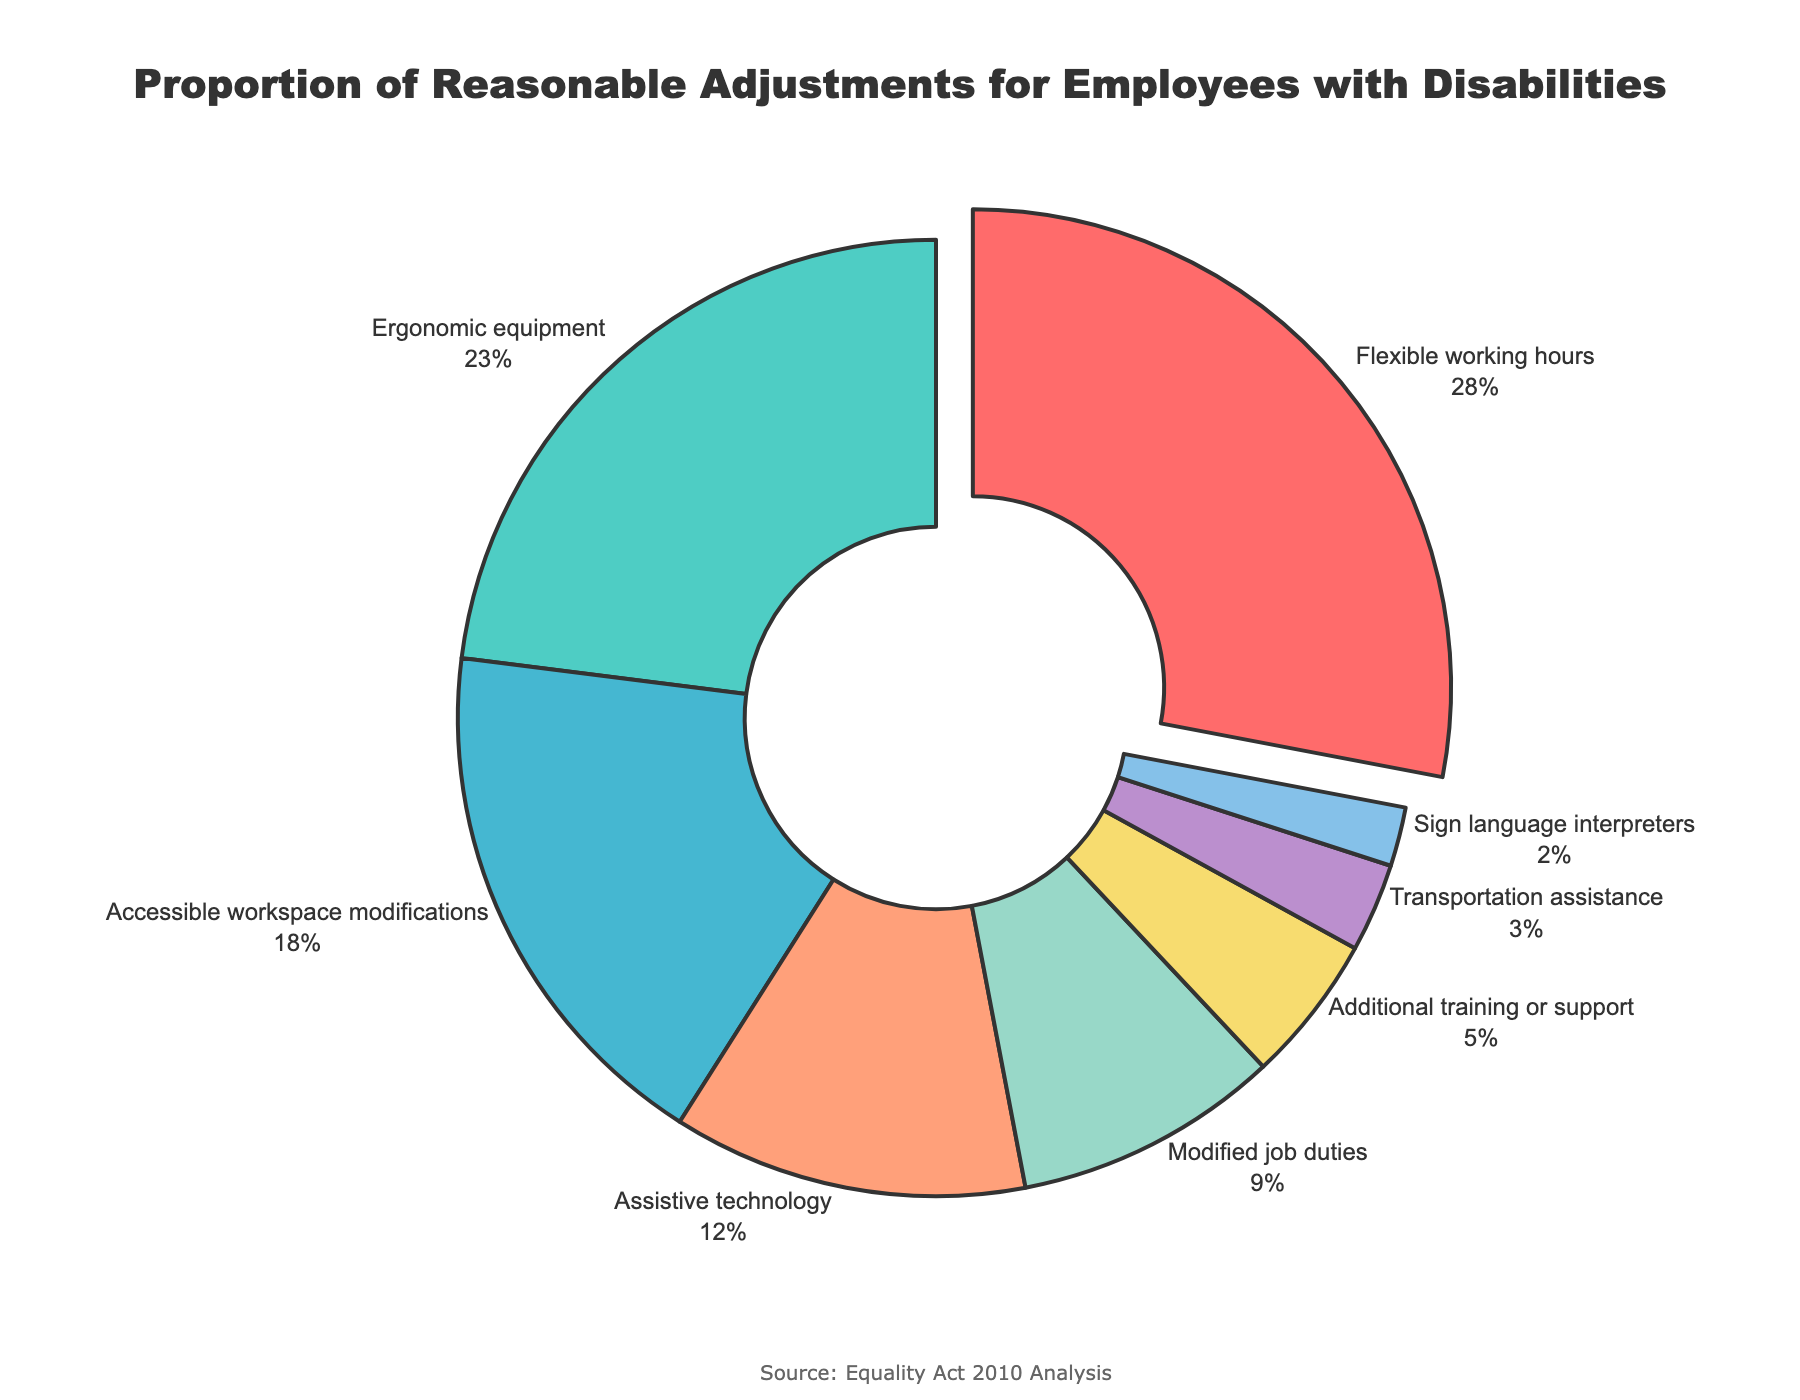What's the category with the highest proportion of reasonable adjustments? The category with the highest percentage in the pie chart is depicted with a slight pull-out effect, and labeled as "Flexible working hours" with 28%.
Answer: Flexible working hours What is the combined percentage of "Ergonomic equipment" and "Accessible workspace modifications"? The percentages for "Ergonomic equipment" and "Accessible workspace modifications" are 23% and 18% respectively. Adding these together, we get 23% + 18% = 41%.
Answer: 41% Which category has a lower proportion: "Modified job duties" or "Assistive technology"? By comparing the percentages in the pie chart, "Modified job duties" has a percentage of 9% and "Assistive technology" has 12%. Since 9% < 12%, "Modified job duties" has a lower proportion.
Answer: Modified job duties What's the difference in the proportion between the highest and the lowest categories? The highest proportion is for "Flexible working hours" at 28%. The lowest proportion is for "Sign language interpreters" at 2%. The difference is 28% - 2% = 26%.
Answer: 26% What is the total percentage of the three least common reasonable adjustments? The three least common categories are "Sign language interpreters" (2%), "Transportation assistance" (3%), and "Additional training or support" (5%). Adding these together, we get 2% + 3% + 5% = 10%.
Answer: 10% How much more common is "Ergonomic equipment" compared to "Modified job duties"? "Ergonomic equipment" is 23% and "Modified job duties" is 9%. To find how much more common it is: 23% - 9% = 14%.
Answer: 14% What's the total percentage for all the categories related to physical modifications? The categories related to physical modifications are "Ergonomic equipment" (23%), "Accessible workspace modifications" (18%), "Transportation assistance" (3%). Adding these together, we get 23% + 18% + 3% = 44%.
Answer: 44% What's the proportion of categories that each constitute less than 10%? The categories with less than 10% are "Modified job duties" (9%), "Additional training or support" (5%), "Transportation assistance" (3%), and "Sign language interpreters" (2%). These total to 9% + 5% + 3% + 2% = 19%.
Answer: 19% Which visual cue allows you to identify the highest proportion category? The highest proportion category "Flexible working hours" is identified by a slight pull-out effect and its label showing 28%.
Answer: Pull-out effect Is the proportion of "Assistive technology" more or less than half of "Flexible working hours"? "Flexible working hours" is 28% and "Assistive technology" is 12%. Half of 28% is 14%. Since 12% < 14%, it is less than half.
Answer: Less 